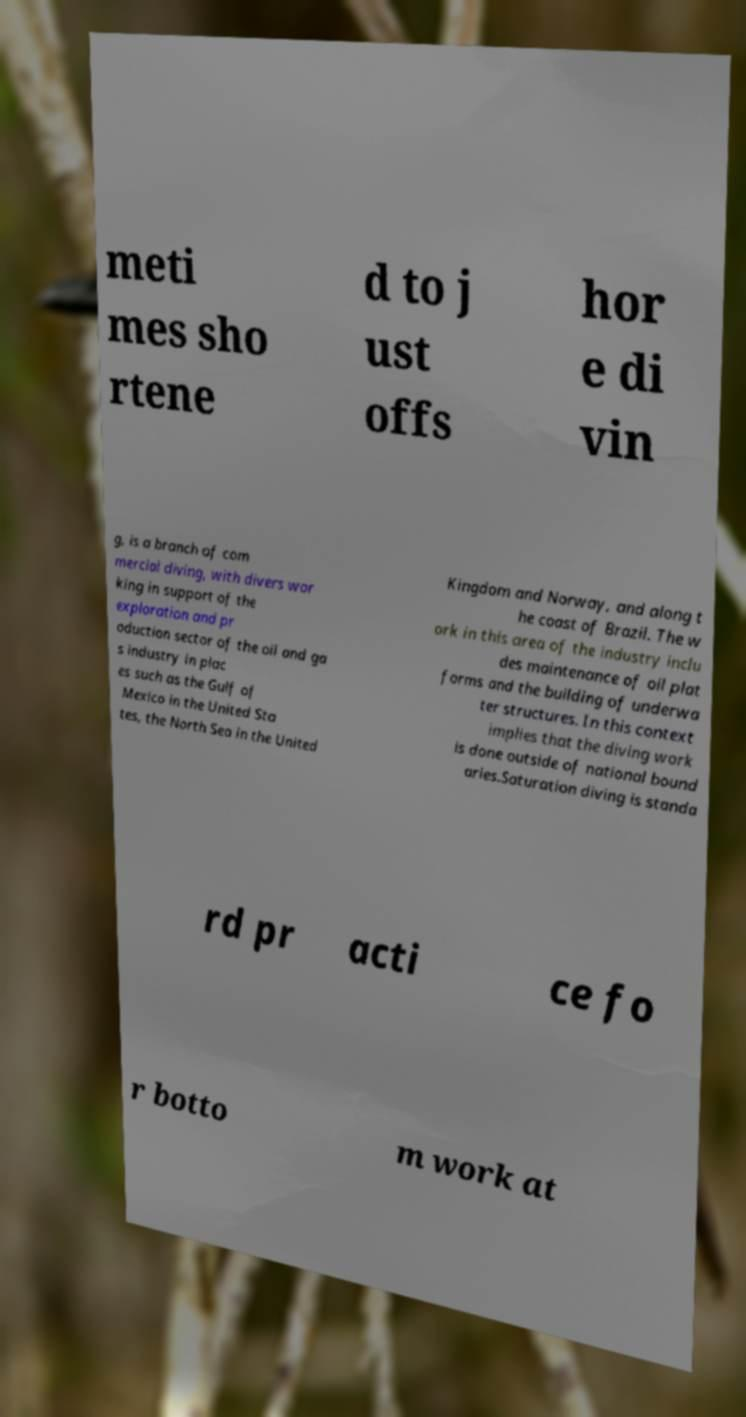Could you extract and type out the text from this image? meti mes sho rtene d to j ust offs hor e di vin g, is a branch of com mercial diving, with divers wor king in support of the exploration and pr oduction sector of the oil and ga s industry in plac es such as the Gulf of Mexico in the United Sta tes, the North Sea in the United Kingdom and Norway, and along t he coast of Brazil. The w ork in this area of the industry inclu des maintenance of oil plat forms and the building of underwa ter structures. In this context implies that the diving work is done outside of national bound aries.Saturation diving is standa rd pr acti ce fo r botto m work at 